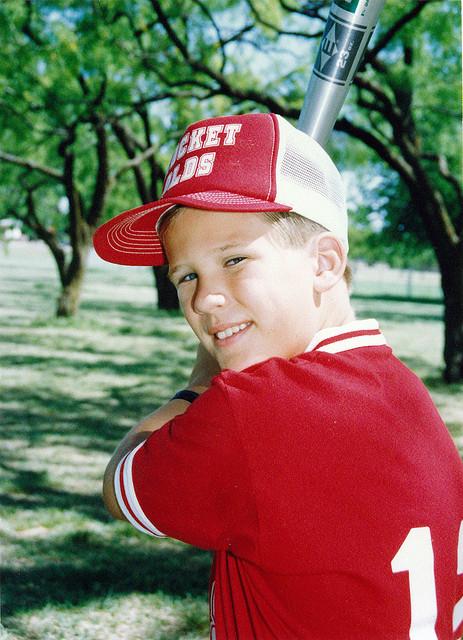What are his eyes doing?
Short answer required. Squinting. What metal is the bat made out of?
Write a very short answer. Aluminum. What color is his shirt?
Concise answer only. Red. What kind of trees are in the background?
Quick response, please. Oak. 